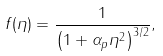Convert formula to latex. <formula><loc_0><loc_0><loc_500><loc_500>f ( \eta ) = \frac { 1 } { \left ( 1 + \alpha _ { p } \eta ^ { 2 } \right ) ^ { 3 / 2 } } ,</formula> 